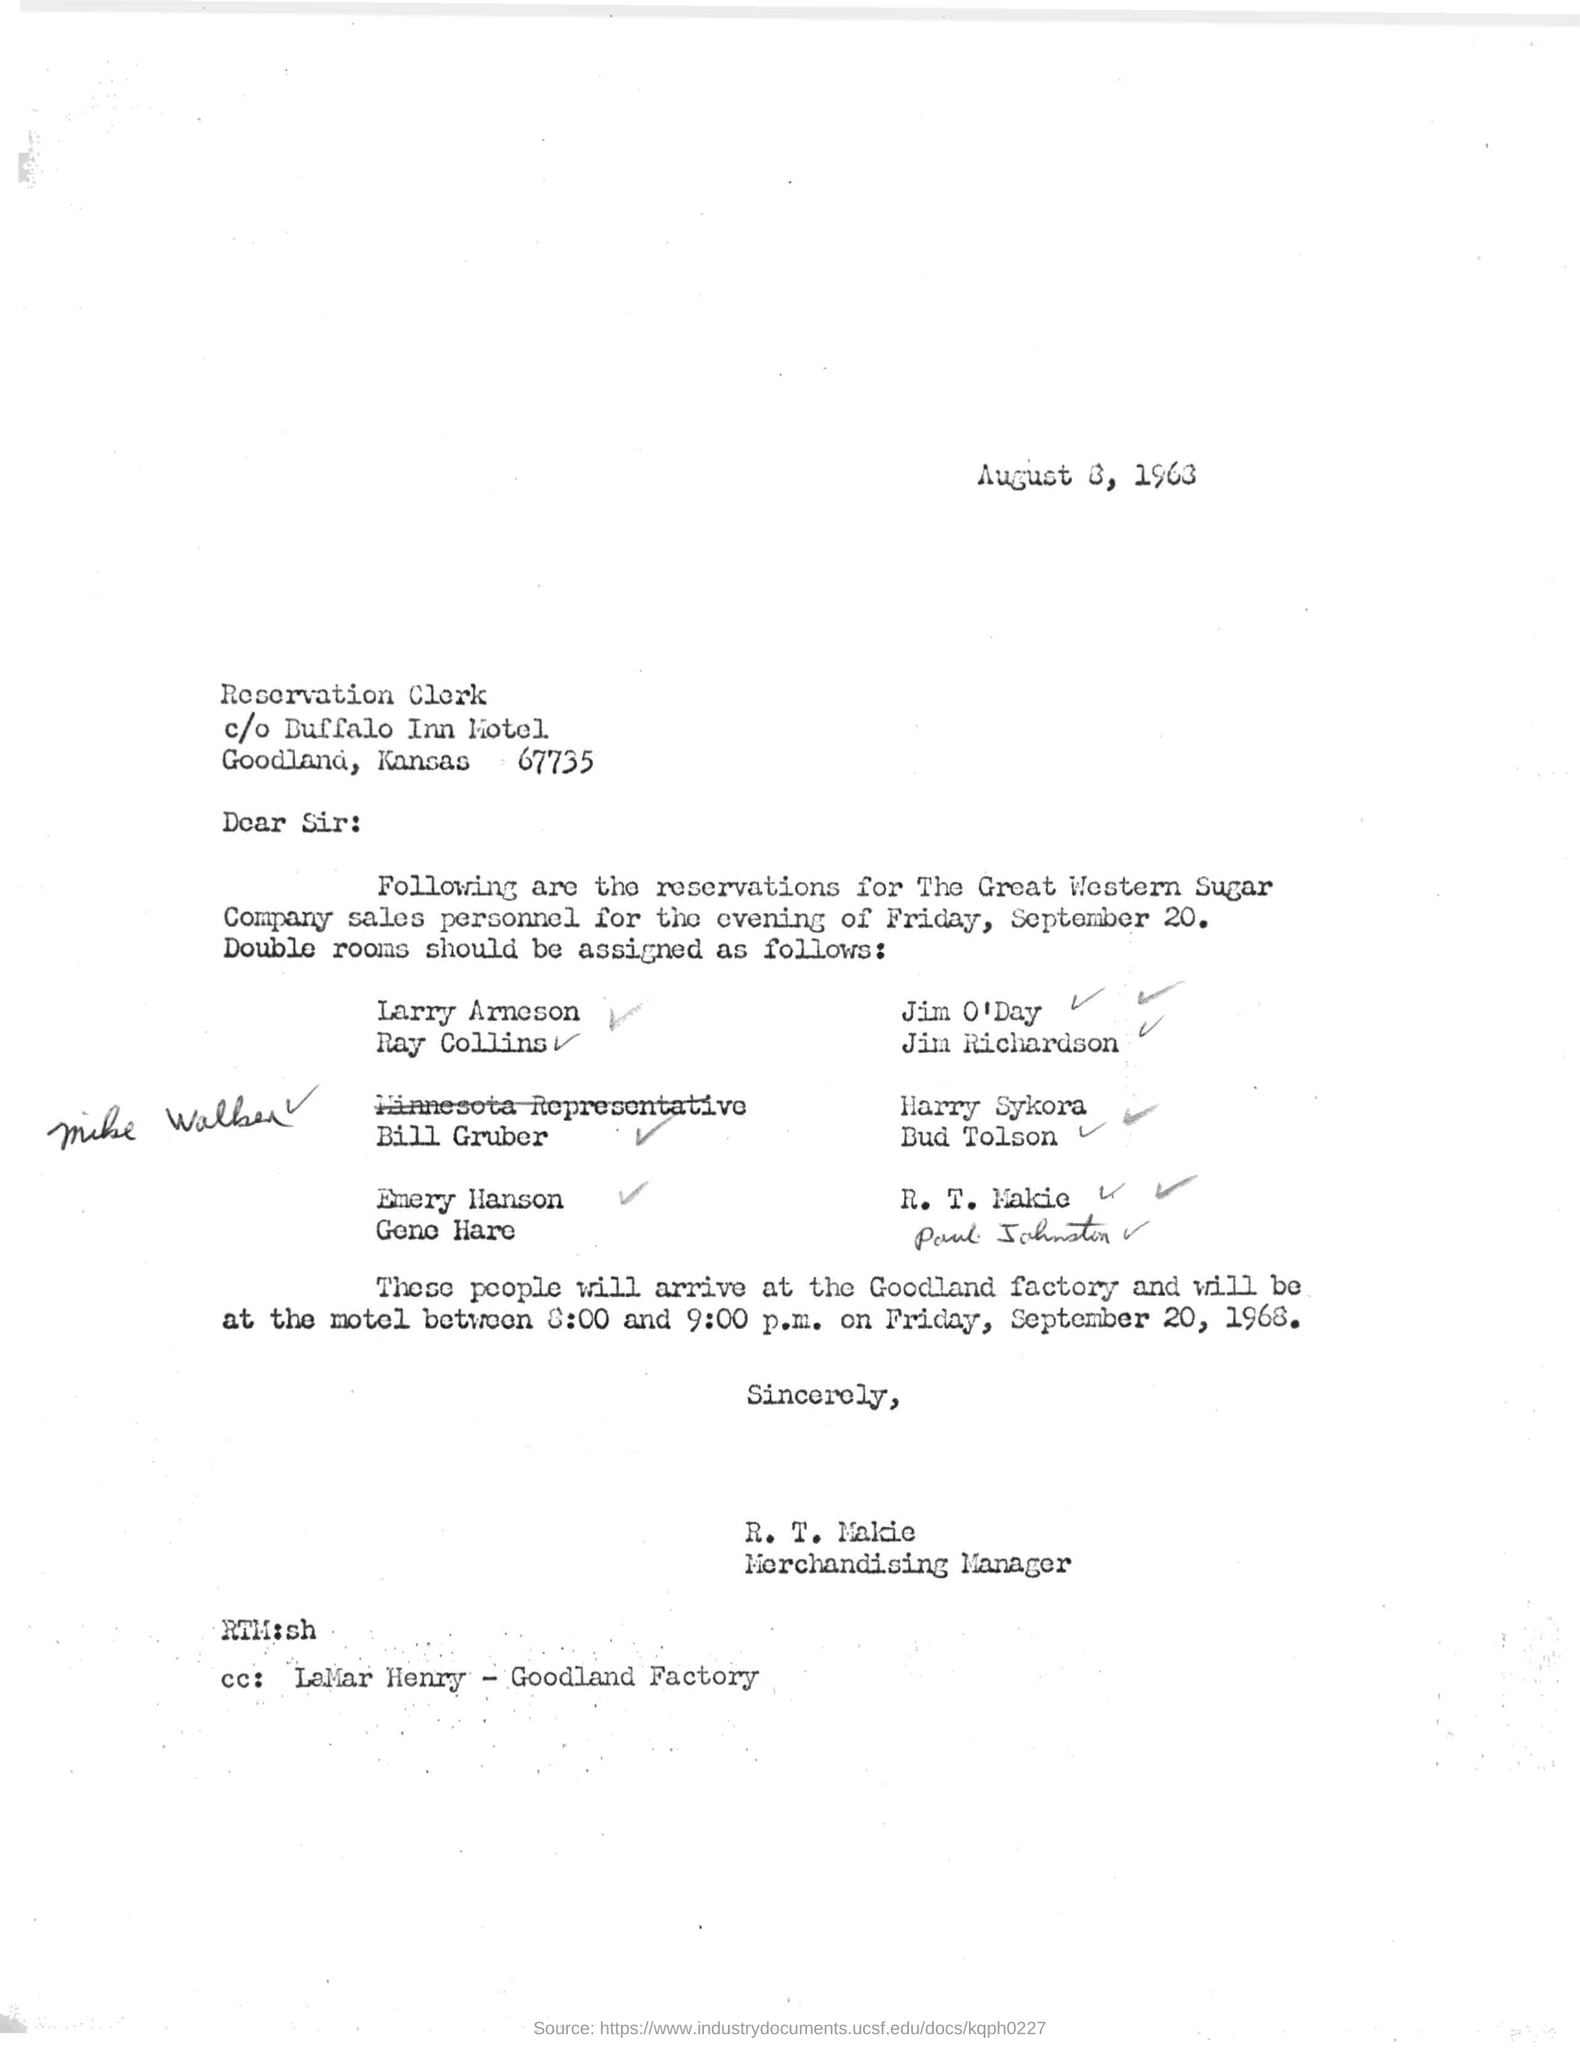Point out several critical features in this image. The sender's designation is Merchandising Manager. The date mentioned in this letter is August 8, 1963. The sender of this letter is R. T. Makie. The reservation date mentioned in this letter is September 20.... 